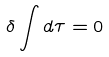Convert formula to latex. <formula><loc_0><loc_0><loc_500><loc_500>\delta \int d \tau = 0</formula> 